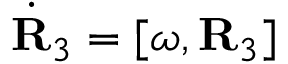<formula> <loc_0><loc_0><loc_500><loc_500>\dot { R } _ { 3 } = [ { \boldsymbol \omega } , { R } _ { 3 } ]</formula> 